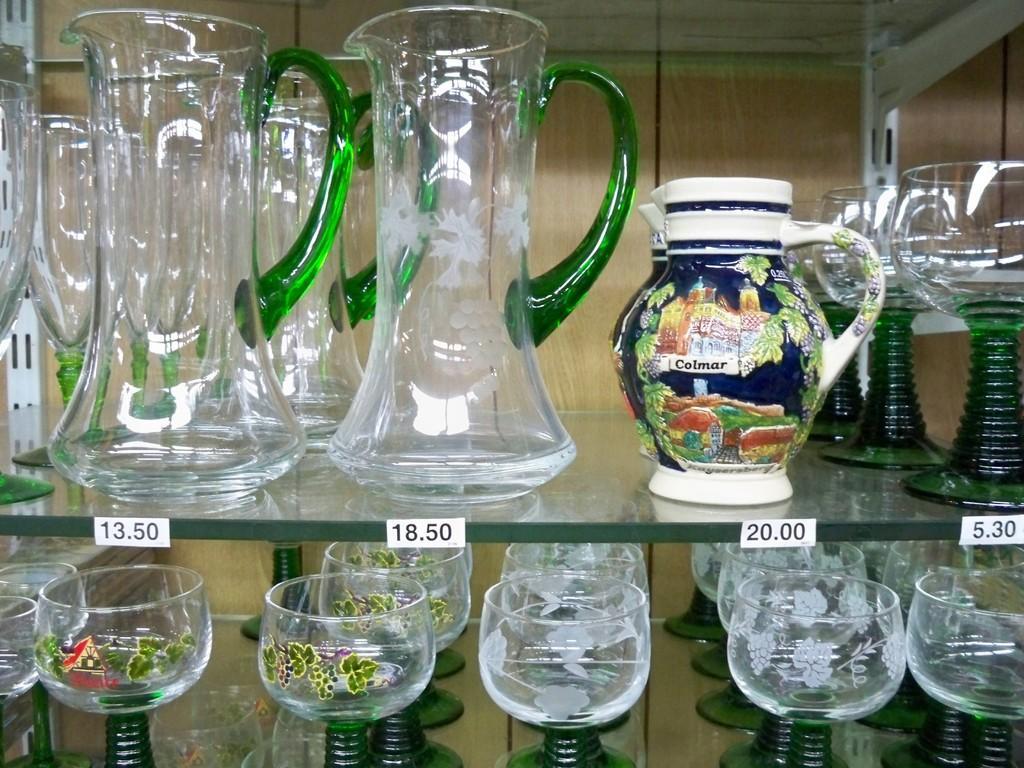Describe this image in one or two sentences. In this image there is a glass shelves on which there are jugs and glasses. In the middle we can see that there are number stickers which are stick to the glass. In the background there is a wooden wall. 